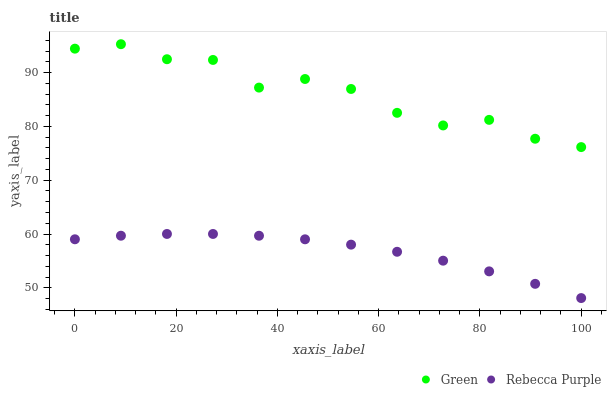Does Rebecca Purple have the minimum area under the curve?
Answer yes or no. Yes. Does Green have the maximum area under the curve?
Answer yes or no. Yes. Does Rebecca Purple have the maximum area under the curve?
Answer yes or no. No. Is Rebecca Purple the smoothest?
Answer yes or no. Yes. Is Green the roughest?
Answer yes or no. Yes. Is Rebecca Purple the roughest?
Answer yes or no. No. Does Rebecca Purple have the lowest value?
Answer yes or no. Yes. Does Green have the highest value?
Answer yes or no. Yes. Does Rebecca Purple have the highest value?
Answer yes or no. No. Is Rebecca Purple less than Green?
Answer yes or no. Yes. Is Green greater than Rebecca Purple?
Answer yes or no. Yes. Does Rebecca Purple intersect Green?
Answer yes or no. No. 